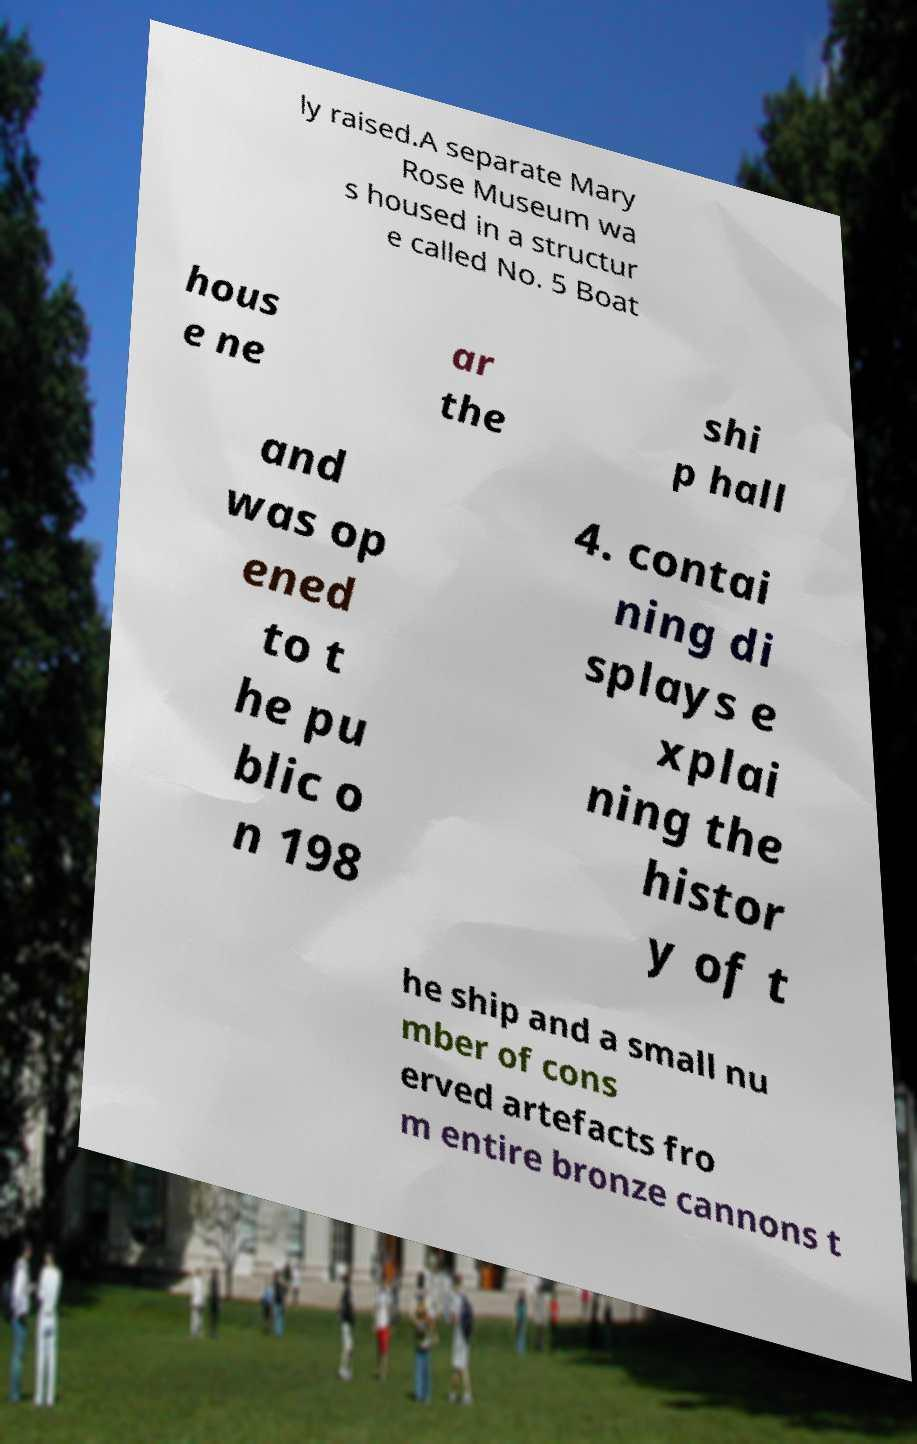Could you assist in decoding the text presented in this image and type it out clearly? ly raised.A separate Mary Rose Museum wa s housed in a structur e called No. 5 Boat hous e ne ar the shi p hall and was op ened to t he pu blic o n 198 4. contai ning di splays e xplai ning the histor y of t he ship and a small nu mber of cons erved artefacts fro m entire bronze cannons t 